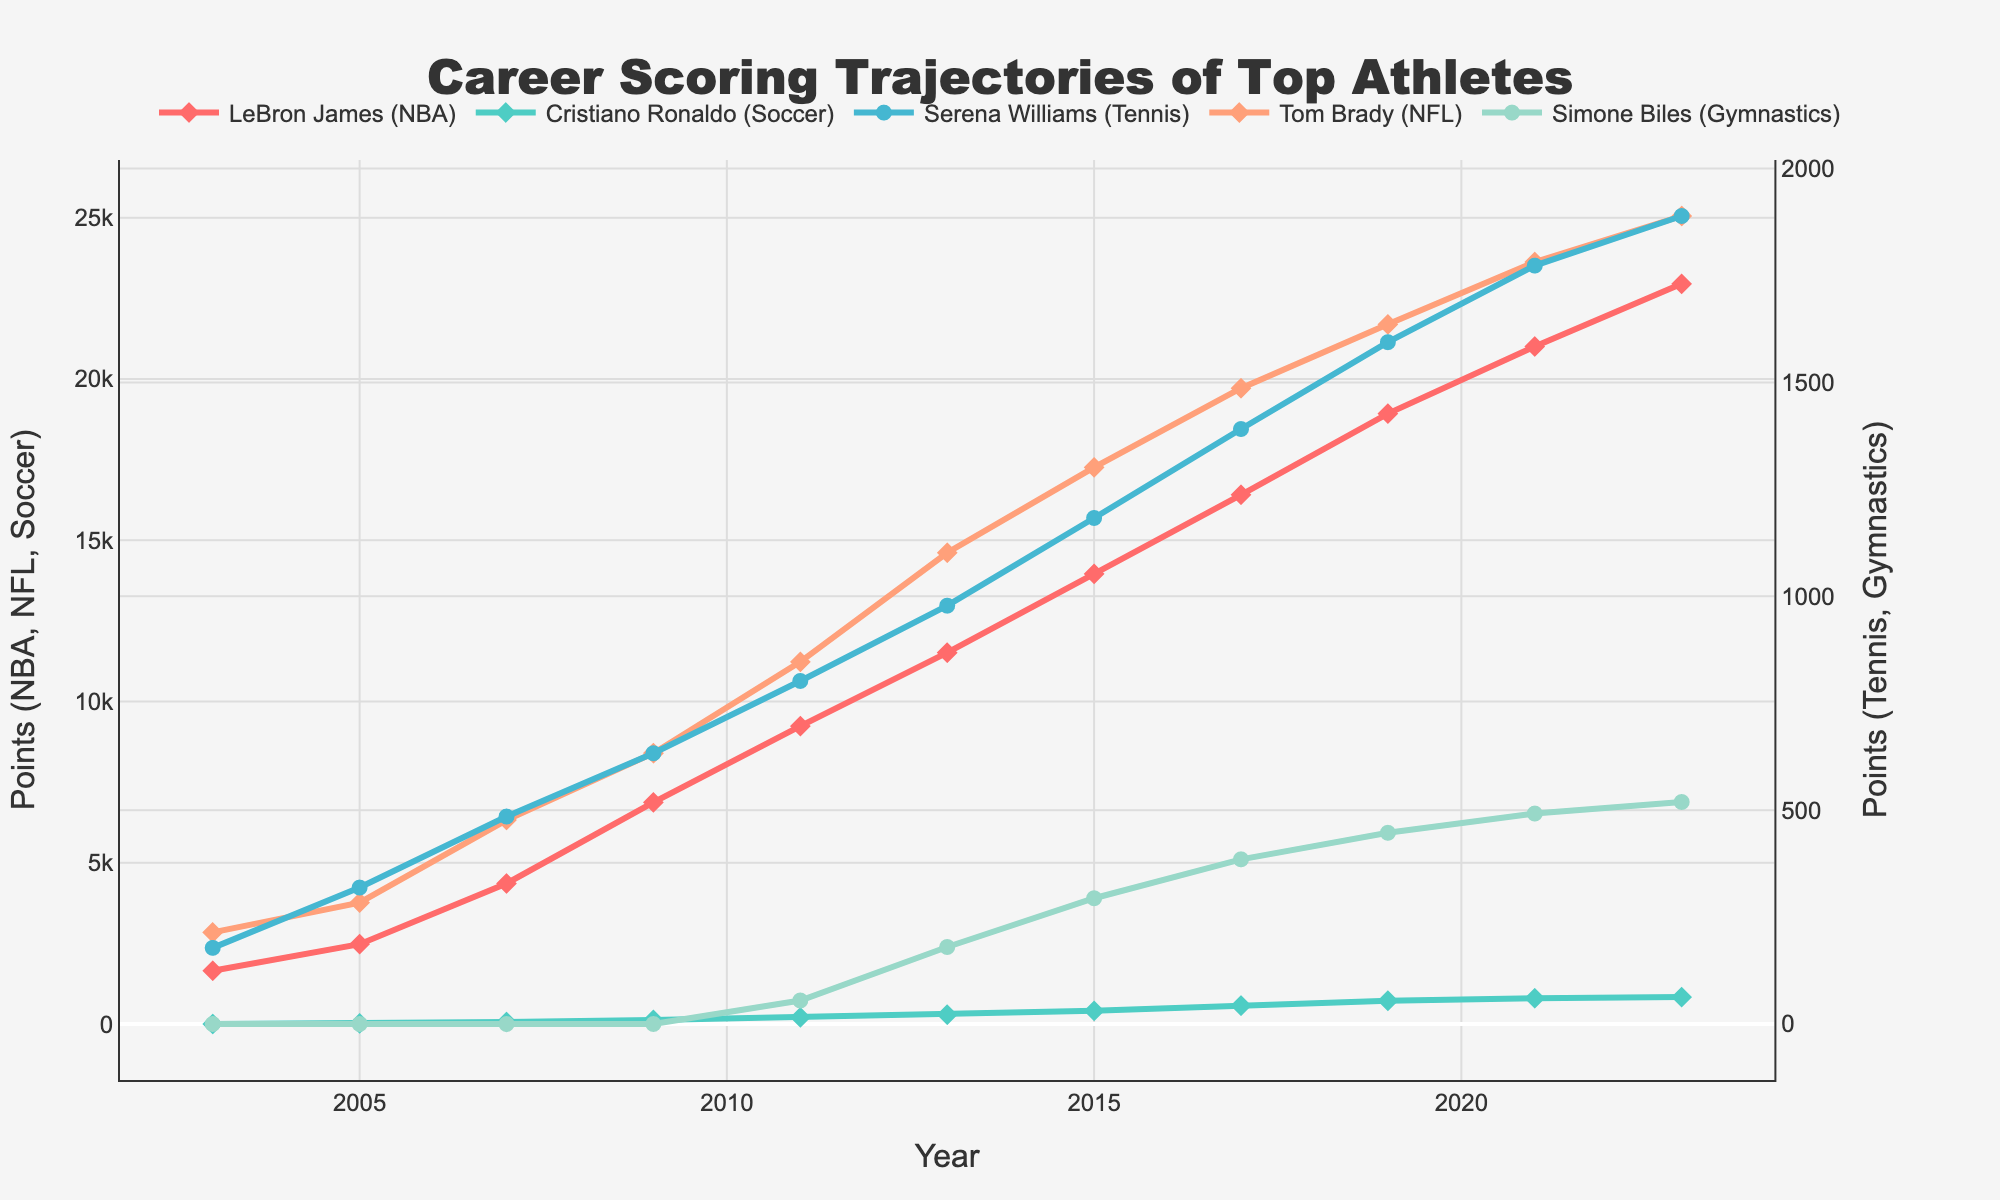What was the highest score reached by LeBron James by 2023? Look at the plot and identify the highest point for LeBron James (red line with diamond markers). By 2023, LeBron James reached 22,948 points.
Answer: 22,948 How many more points did Tom Brady score in 2023 compared to 2019? Look at the end points for Tom Brady (orange line with diamond markers) at 2023 and 2019. In 2023, he scored 25,051 points and in 2019, he scored 21,693 points. So, 25,051 - 21,693 = 3,358.
Answer: 3,358 Which athlete showed the most rapid increase in their score from 2017 to 2021? Compare the slopes of the lines for each athlete between 2017 and 2021. Serena Williams (purple line with circle markers) went from 1,391 in 2017 to 1,773 in 2021, which is an increase of 382 points. This is the steepest slope among all athletes.
Answer: Serena Williams In what year did Simone Biles first score over 100 points? Locate the point where Simone Biles (green line with circle markers) first crosses the 100-point mark. This occurred in 2011 with 55 points. She scored over 100 points by 2013 when she achieved 180 points.
Answer: 2013 On average, how many points did Cristiano Ronaldo score per year between 2009 and 2021? Consider Cristiano Ronaldo's scores in 2009 and 2021, which are 131 points and 801 points, respectively. The period between 2009 and 2021 is 12 years. Calculate the average: (801 - 131) / 12 ≈ 55.75 points per year.
Answer: 55.75 points per year Who scored more points in 2011: LeBron James or Tom Brady? Compare the points of LeBron James (9,237 points) and Tom Brady (11,229 points) in 2011. Tom Brady scored more points.
Answer: Tom Brady Which athlete had a steady increase without any dips in their score throughout the years presented? Examine the graph to identify any athlete whose line consistently rises without any drops. LeBron James (red line with diamond markers) shows a steady upward trajectory without any dips.
Answer: LeBron James How does the total number of points scored by Simone Biles in 2023 compare to the cumulative points of Serena Williams in 2023? Identify the points for both athletes in 2023. Simone Biles (green line with circle markers) scored 519 points, and Serena Williams (purple line with circle markers) scored 1,889 points.
Answer: Serena Williams scored more What is the difference between Simone Biles' and Cristiano Ronaldo's scores in 2023? Compare Simone Biles' score in 2023 (519 points) and Cristiano Ronaldo's score in 2023 (837 points): 837 - 519 = 318.
Answer: 318 Which year saw the highest increase in Tom Brady's scores? Check the slopes of Tom Brady's line (orange line with diamond markers) and identify the steepest segment. Between 2007 and 2009, he went from 6,325 to 8,398 points, an increase of 2,073 points.
Answer: 2007 to 2009 